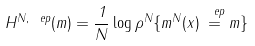<formula> <loc_0><loc_0><loc_500><loc_500>H ^ { N , \ e p } ( m ) = \frac { 1 } { N } \log \rho ^ { N } \{ m ^ { N } ( x ) \stackrel { \ e p } { = } m \}</formula> 